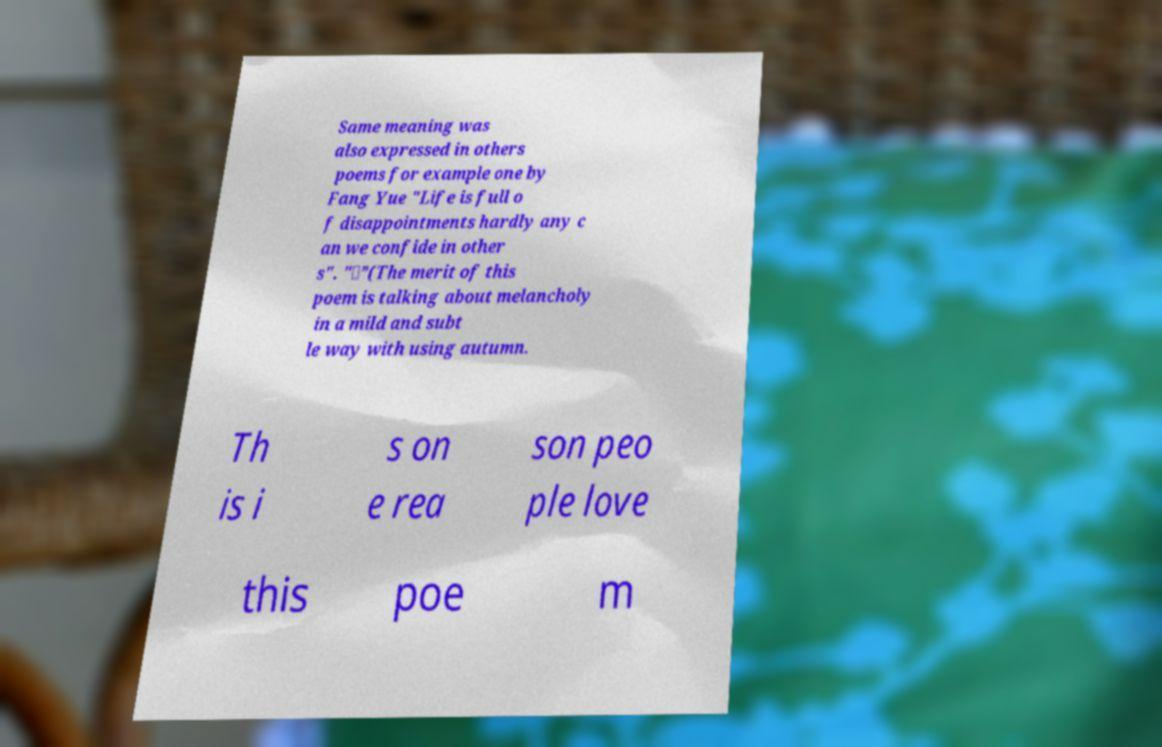Could you assist in decoding the text presented in this image and type it out clearly? Same meaning was also expressed in others poems for example one by Fang Yue "Life is full o f disappointments hardly any c an we confide in other s". "。”(The merit of this poem is talking about melancholy in a mild and subt le way with using autumn. Th is i s on e rea son peo ple love this poe m 